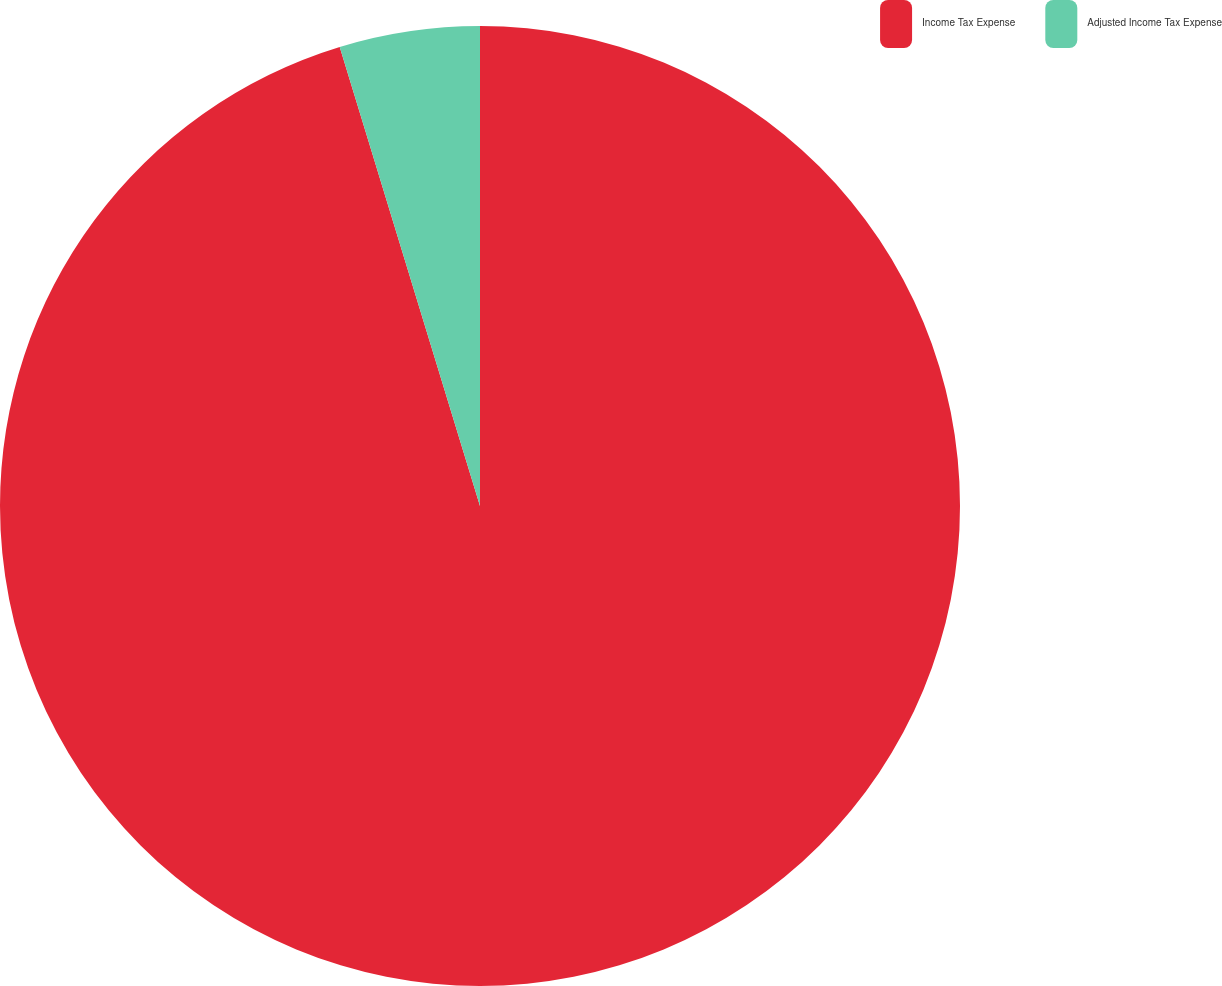Convert chart. <chart><loc_0><loc_0><loc_500><loc_500><pie_chart><fcel>Income Tax Expense<fcel>Adjusted Income Tax Expense<nl><fcel>95.28%<fcel>4.72%<nl></chart> 